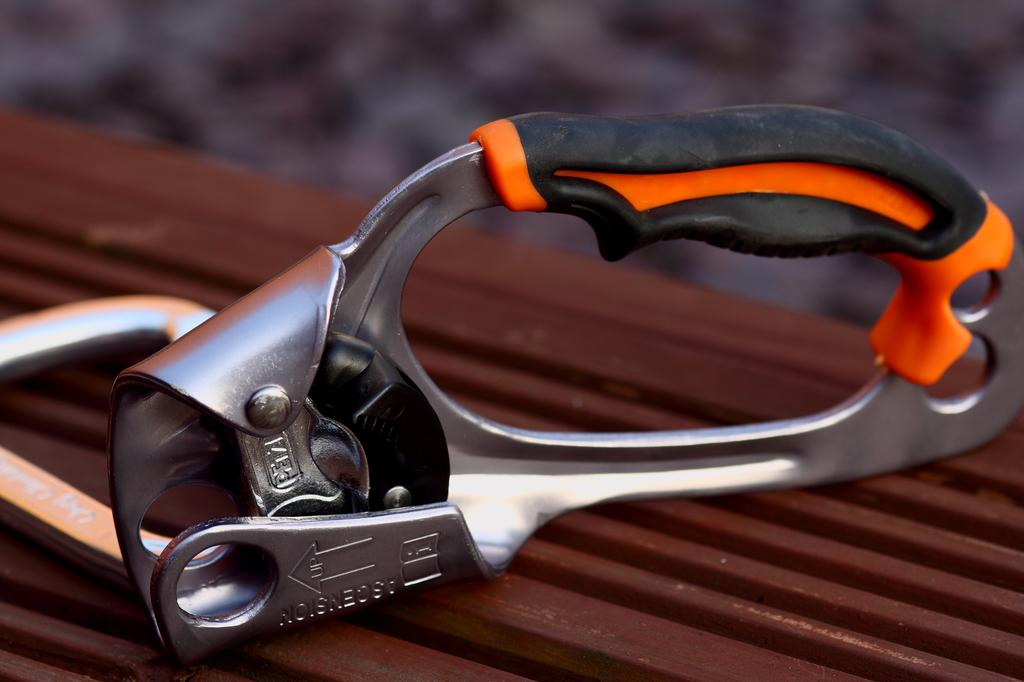What type of object is in the image? There is a mechanical tool in the image. Where is the mechanical tool located? The mechanical tool is on a surface. Can you describe the background of the image? The background of the image is blurred. How does the expert rock the tool in the image? There is no expert or rock present in the image; it only features a mechanical tool on a surface with a blurred background. 